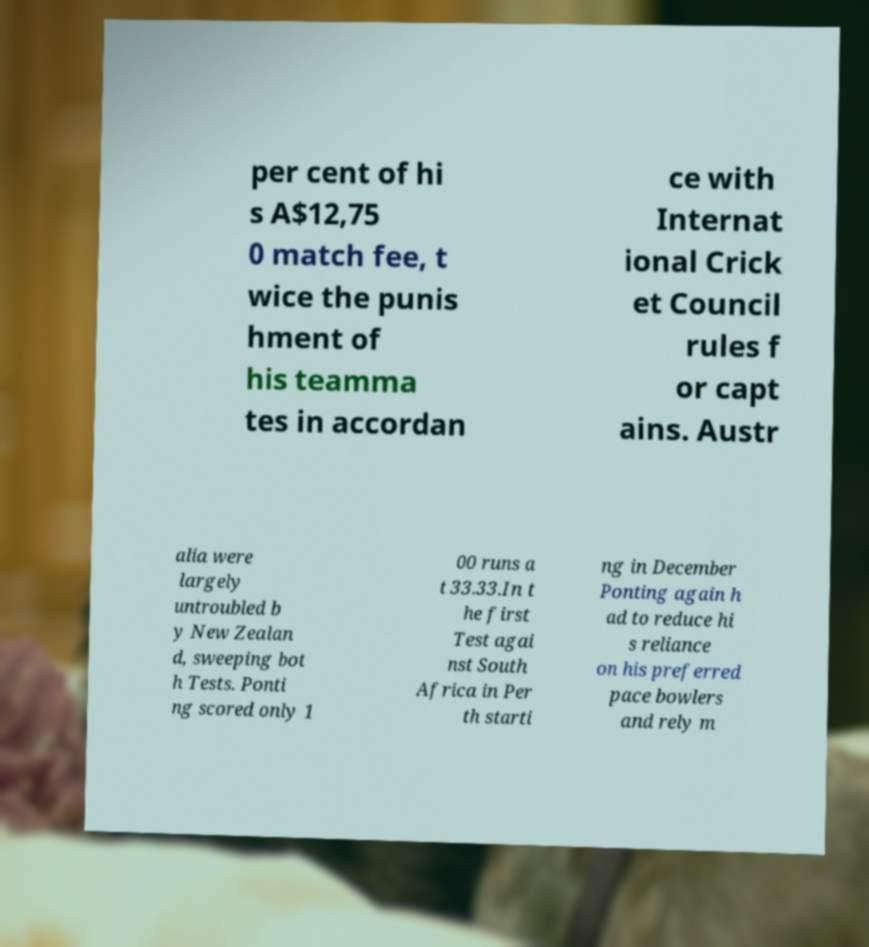Please read and relay the text visible in this image. What does it say? per cent of hi s A$12,75 0 match fee, t wice the punis hment of his teamma tes in accordan ce with Internat ional Crick et Council rules f or capt ains. Austr alia were largely untroubled b y New Zealan d, sweeping bot h Tests. Ponti ng scored only 1 00 runs a t 33.33.In t he first Test agai nst South Africa in Per th starti ng in December Ponting again h ad to reduce hi s reliance on his preferred pace bowlers and rely m 